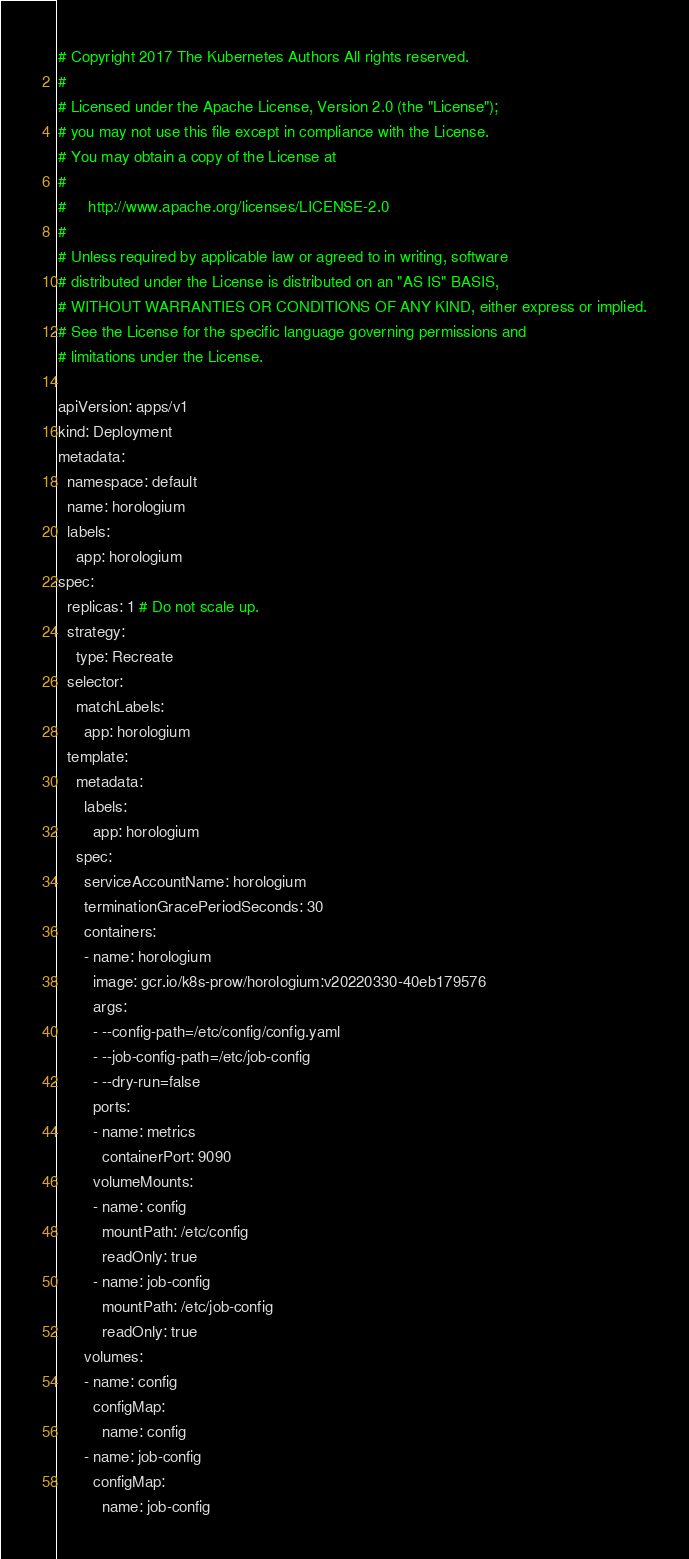Convert code to text. <code><loc_0><loc_0><loc_500><loc_500><_YAML_># Copyright 2017 The Kubernetes Authors All rights reserved.
#
# Licensed under the Apache License, Version 2.0 (the "License");
# you may not use this file except in compliance with the License.
# You may obtain a copy of the License at
#
#     http://www.apache.org/licenses/LICENSE-2.0
#
# Unless required by applicable law or agreed to in writing, software
# distributed under the License is distributed on an "AS IS" BASIS,
# WITHOUT WARRANTIES OR CONDITIONS OF ANY KIND, either express or implied.
# See the License for the specific language governing permissions and
# limitations under the License.

apiVersion: apps/v1
kind: Deployment
metadata:
  namespace: default
  name: horologium
  labels:
    app: horologium
spec:
  replicas: 1 # Do not scale up.
  strategy:
    type: Recreate
  selector:
    matchLabels:
      app: horologium
  template:
    metadata:
      labels:
        app: horologium
    spec:
      serviceAccountName: horologium
      terminationGracePeriodSeconds: 30
      containers:
      - name: horologium
        image: gcr.io/k8s-prow/horologium:v20220330-40eb179576
        args:
        - --config-path=/etc/config/config.yaml
        - --job-config-path=/etc/job-config
        - --dry-run=false
        ports:
        - name: metrics
          containerPort: 9090
        volumeMounts:
        - name: config
          mountPath: /etc/config
          readOnly: true
        - name: job-config
          mountPath: /etc/job-config
          readOnly: true
      volumes:
      - name: config
        configMap:
          name: config
      - name: job-config
        configMap:
          name: job-config
</code> 